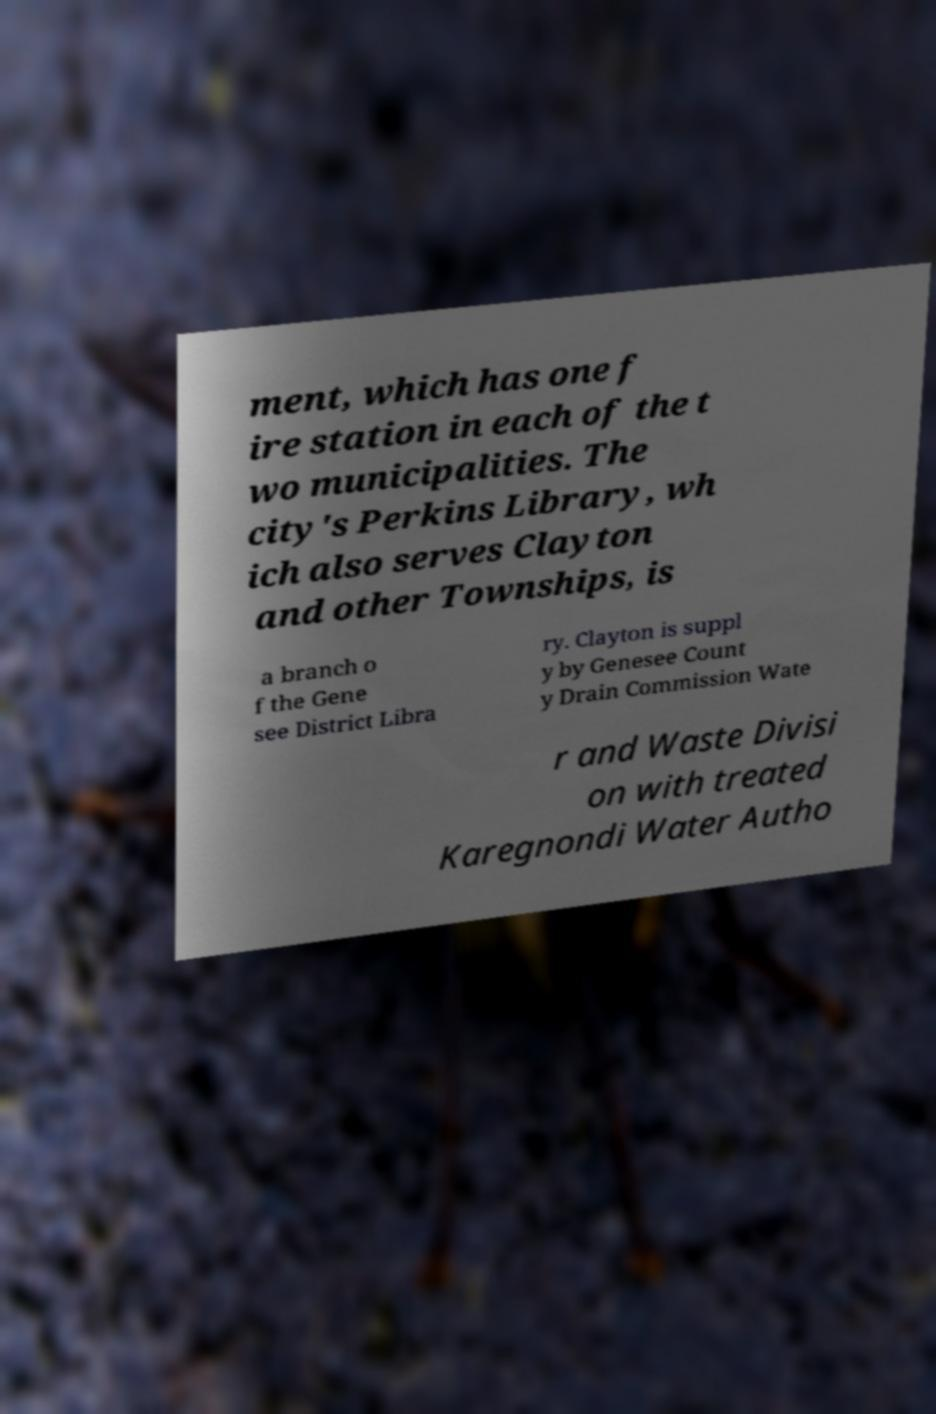Could you extract and type out the text from this image? ment, which has one f ire station in each of the t wo municipalities. The city's Perkins Library, wh ich also serves Clayton and other Townships, is a branch o f the Gene see District Libra ry. Clayton is suppl y by Genesee Count y Drain Commission Wate r and Waste Divisi on with treated Karegnondi Water Autho 